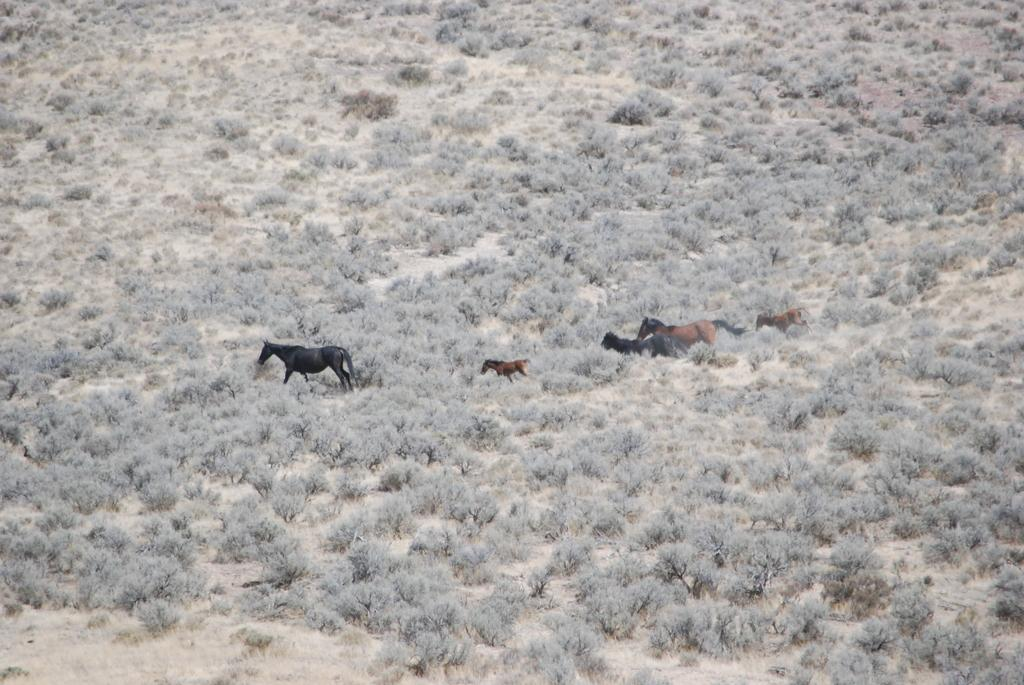What animals are present in the image? There are horses in the image. What type of vegetation can be seen at the bottom of the image? There are plants at the bottom of the image. How many girls are crossing the bridge in the image? There are no girls or bridges present in the image; it features horses and plants. What type of sugar is being used to sweeten the horses in the image? There is no sugar present in the image, and horses do not consume sugar in this context. 